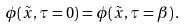<formula> <loc_0><loc_0><loc_500><loc_500>\phi ( \tilde { x } , \tau = 0 ) = \phi ( \tilde { x } , \tau = { \beta } ) \, .</formula> 